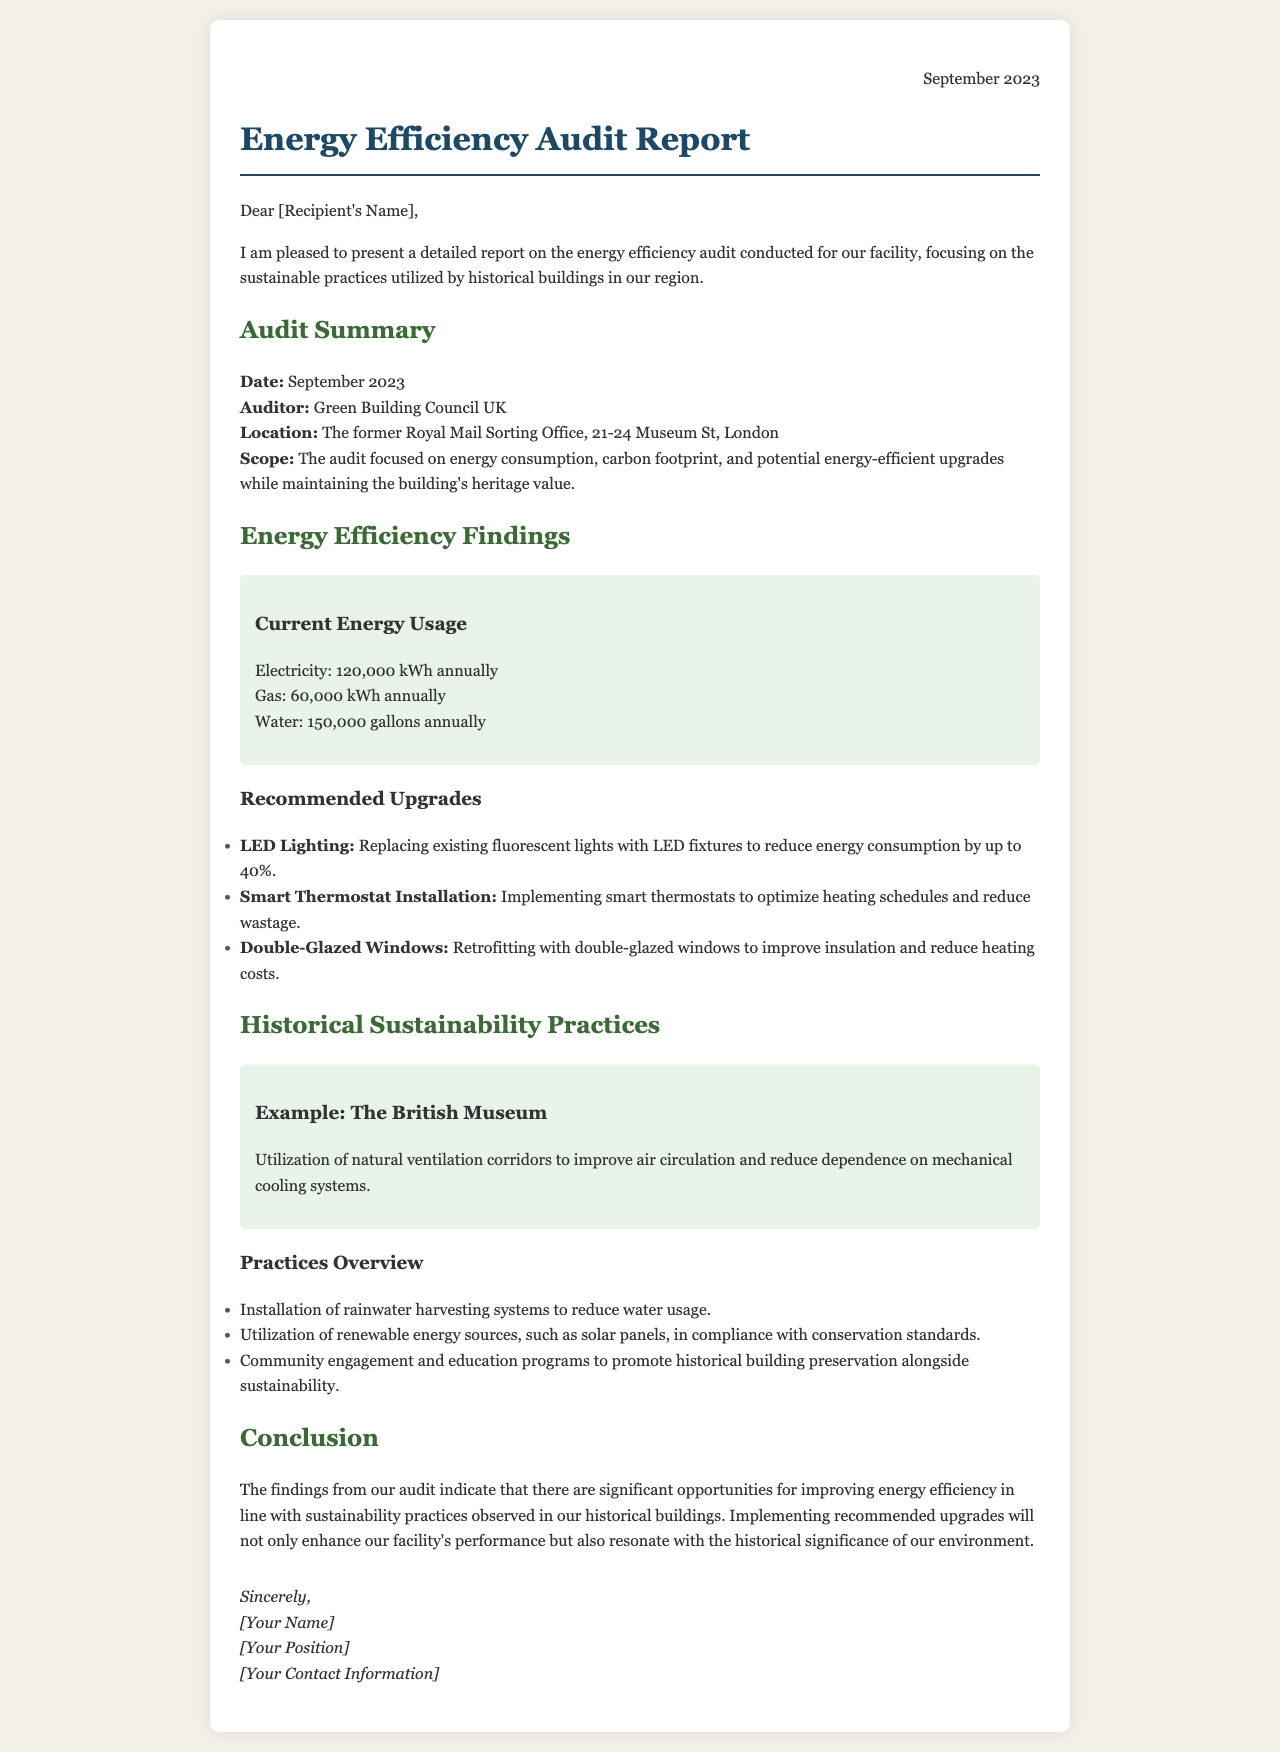What is the date of the audit? The date of the audit is specified in the document as September 2023.
Answer: September 2023 Who conducted the audit? The document states that the audit was conducted by the Green Building Council UK.
Answer: Green Building Council UK What is the annual electricity usage? The document highlights the annual electricity usage of the facility as 120,000 kWh.
Answer: 120,000 kWh What energy-efficient upgrade can reduce energy consumption by up to 40%? The document mentions replacing existing fluorescent lights with LED fixtures as an upgrade that can achieve this reduction.
Answer: LED Lighting Name one historical building mentioned as an example for sustainability practices. The document provides the British Museum as an example of utilizing sustainability practices.
Answer: The British Museum What is one practice to reduce water usage mentioned in the practices overview? The document lists the installation of rainwater harvesting systems as a practice to reduce water usage.
Answer: Rainwater harvesting systems What is the main focus of the energy efficiency audit? The document indicates that the audit focused on energy consumption, carbon footprint, and potential upgrades while preserving heritage value.
Answer: Energy consumption, carbon footprint, potential upgrades What is the significance of the findings from the audit? The findings indicate opportunities for improving energy efficiency in line with sustainability practices observed in historical buildings.
Answer: Improving energy efficiency What type of document is this? The structure and content show that it is a report on an energy efficiency audit for a facility.
Answer: Energy Efficiency Audit Report 